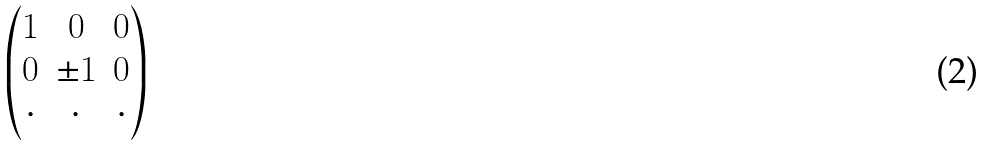Convert formula to latex. <formula><loc_0><loc_0><loc_500><loc_500>\begin{pmatrix} 1 & 0 & 0 \\ 0 & \pm 1 & 0 \\ \cdot & \cdot & \cdot \\ \end{pmatrix}</formula> 